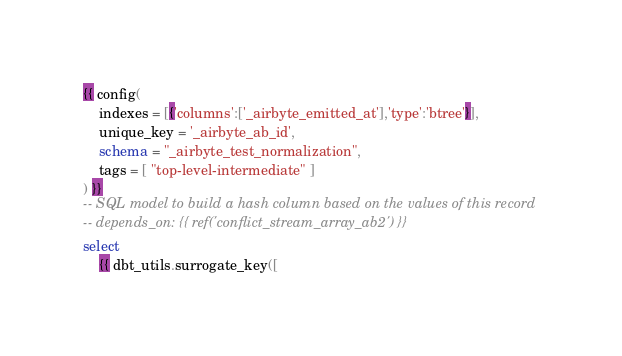<code> <loc_0><loc_0><loc_500><loc_500><_SQL_>{{ config(
    indexes = [{'columns':['_airbyte_emitted_at'],'type':'btree'}],
    unique_key = '_airbyte_ab_id',
    schema = "_airbyte_test_normalization",
    tags = [ "top-level-intermediate" ]
) }}
-- SQL model to build a hash column based on the values of this record
-- depends_on: {{ ref('conflict_stream_array_ab2') }}
select
    {{ dbt_utils.surrogate_key([</code> 